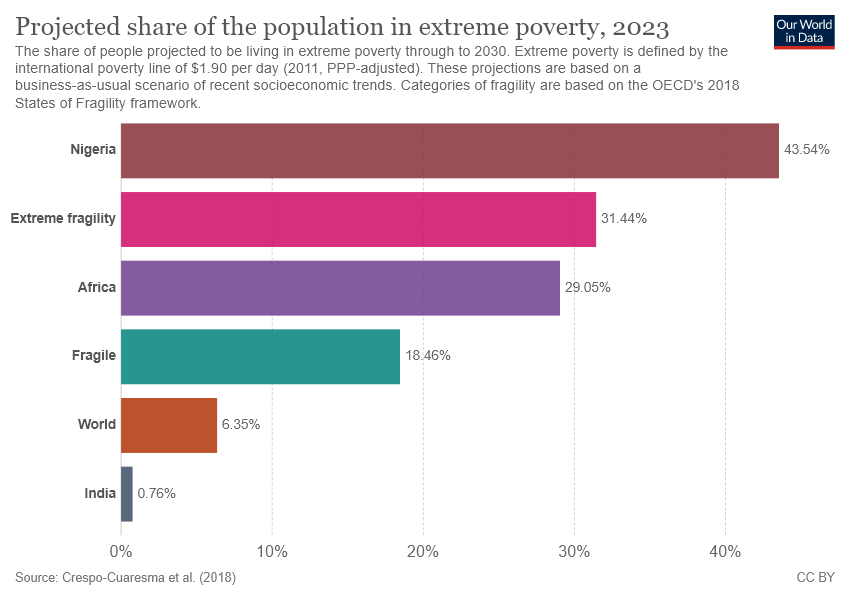Highlight a few significant elements in this photo. Nigeria is the country with the longest bar in the world. 